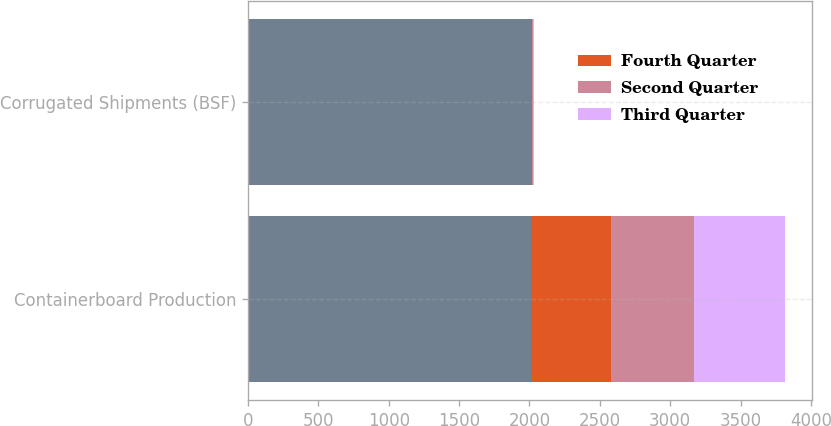<chart> <loc_0><loc_0><loc_500><loc_500><stacked_bar_chart><ecel><fcel>Containerboard Production<fcel>Corrugated Shipments (BSF)<nl><fcel>nan<fcel>2010<fcel>2010<nl><fcel>Fourth Quarter<fcel>569<fcel>7.6<nl><fcel>Second Quarter<fcel>589<fcel>7.9<nl><fcel>Third Quarter<fcel>646<fcel>7.8<nl></chart> 